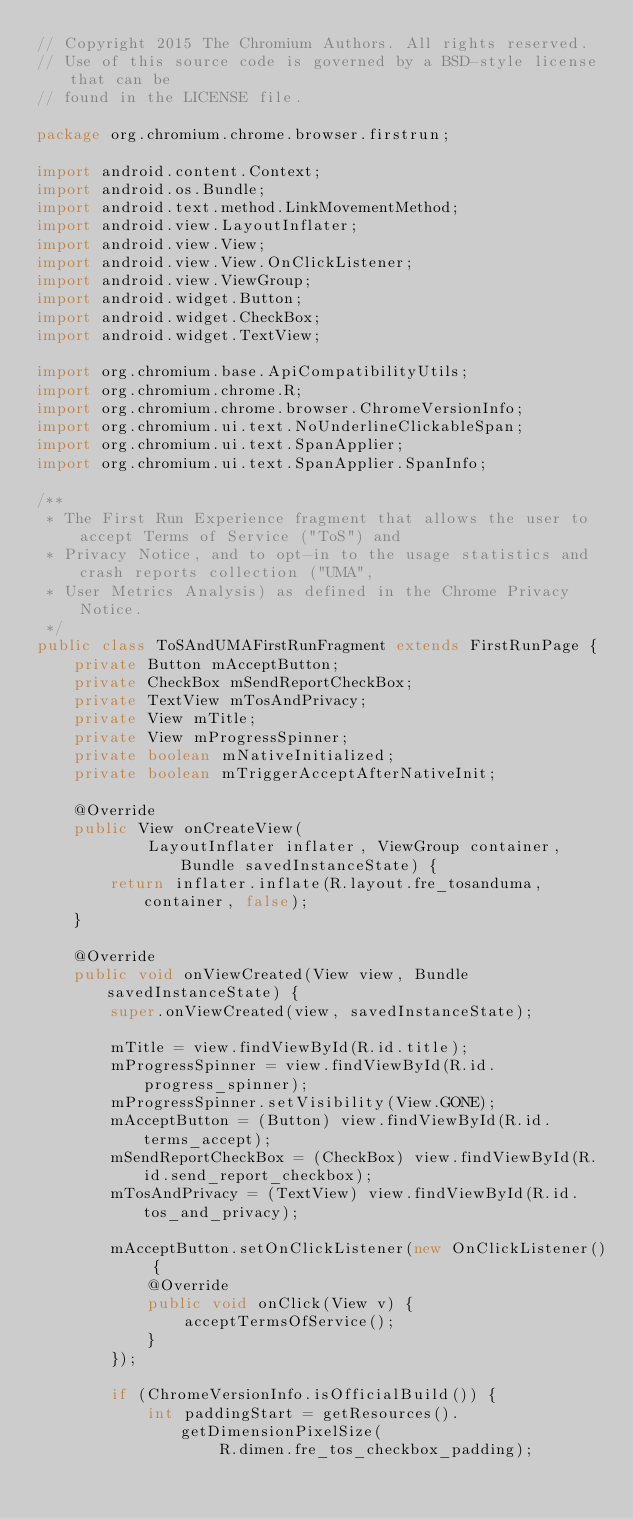<code> <loc_0><loc_0><loc_500><loc_500><_Java_>// Copyright 2015 The Chromium Authors. All rights reserved.
// Use of this source code is governed by a BSD-style license that can be
// found in the LICENSE file.

package org.chromium.chrome.browser.firstrun;

import android.content.Context;
import android.os.Bundle;
import android.text.method.LinkMovementMethod;
import android.view.LayoutInflater;
import android.view.View;
import android.view.View.OnClickListener;
import android.view.ViewGroup;
import android.widget.Button;
import android.widget.CheckBox;
import android.widget.TextView;

import org.chromium.base.ApiCompatibilityUtils;
import org.chromium.chrome.R;
import org.chromium.chrome.browser.ChromeVersionInfo;
import org.chromium.ui.text.NoUnderlineClickableSpan;
import org.chromium.ui.text.SpanApplier;
import org.chromium.ui.text.SpanApplier.SpanInfo;

/**
 * The First Run Experience fragment that allows the user to accept Terms of Service ("ToS") and
 * Privacy Notice, and to opt-in to the usage statistics and crash reports collection ("UMA",
 * User Metrics Analysis) as defined in the Chrome Privacy Notice.
 */
public class ToSAndUMAFirstRunFragment extends FirstRunPage {
    private Button mAcceptButton;
    private CheckBox mSendReportCheckBox;
    private TextView mTosAndPrivacy;
    private View mTitle;
    private View mProgressSpinner;
    private boolean mNativeInitialized;
    private boolean mTriggerAcceptAfterNativeInit;

    @Override
    public View onCreateView(
            LayoutInflater inflater, ViewGroup container, Bundle savedInstanceState) {
        return inflater.inflate(R.layout.fre_tosanduma, container, false);
    }

    @Override
    public void onViewCreated(View view, Bundle savedInstanceState) {
        super.onViewCreated(view, savedInstanceState);

        mTitle = view.findViewById(R.id.title);
        mProgressSpinner = view.findViewById(R.id.progress_spinner);
        mProgressSpinner.setVisibility(View.GONE);
        mAcceptButton = (Button) view.findViewById(R.id.terms_accept);
        mSendReportCheckBox = (CheckBox) view.findViewById(R.id.send_report_checkbox);
        mTosAndPrivacy = (TextView) view.findViewById(R.id.tos_and_privacy);

        mAcceptButton.setOnClickListener(new OnClickListener() {
            @Override
            public void onClick(View v) {
                acceptTermsOfService();
            }
        });

        if (ChromeVersionInfo.isOfficialBuild()) {
            int paddingStart = getResources().getDimensionPixelSize(
                    R.dimen.fre_tos_checkbox_padding);</code> 